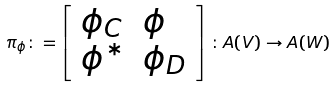<formula> <loc_0><loc_0><loc_500><loc_500>\pi _ { \phi } \colon = \left [ \begin{array} { l l } \phi _ { C } & \phi \\ \phi ^ { * } & \phi _ { D } \end{array} \right ] \colon A ( V ) \rightarrow A ( W )</formula> 